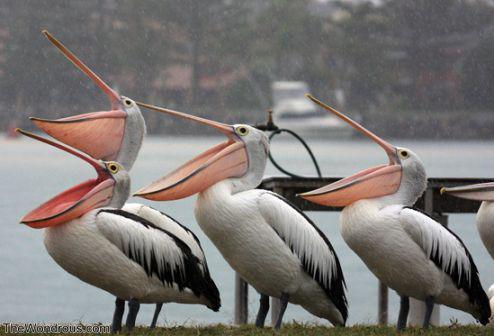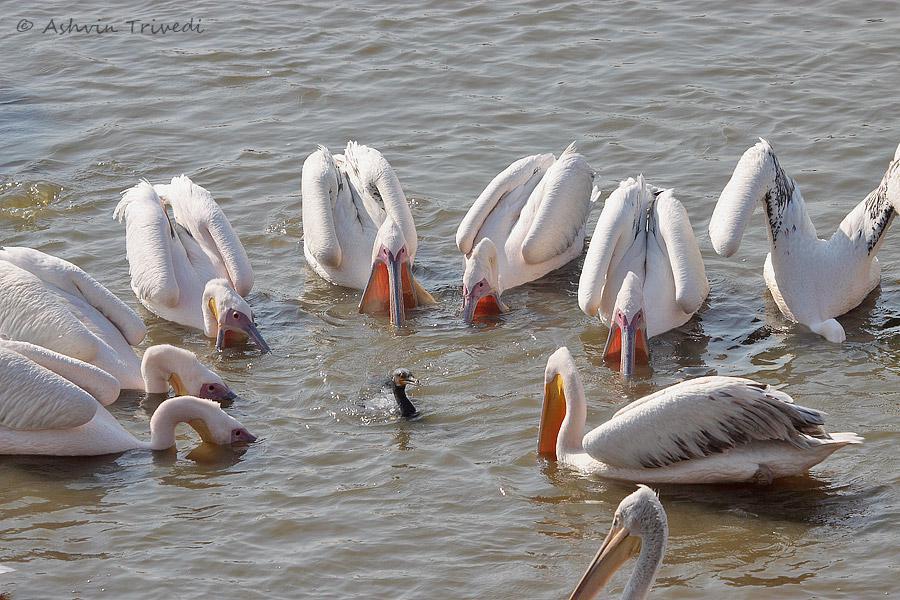The first image is the image on the left, the second image is the image on the right. Evaluate the accuracy of this statement regarding the images: "The rightmost image has 3 birds.". Is it true? Answer yes or no. No. The first image is the image on the left, the second image is the image on the right. Given the left and right images, does the statement "An image features exactly three pelicans, all facing the same way." hold true? Answer yes or no. Yes. 